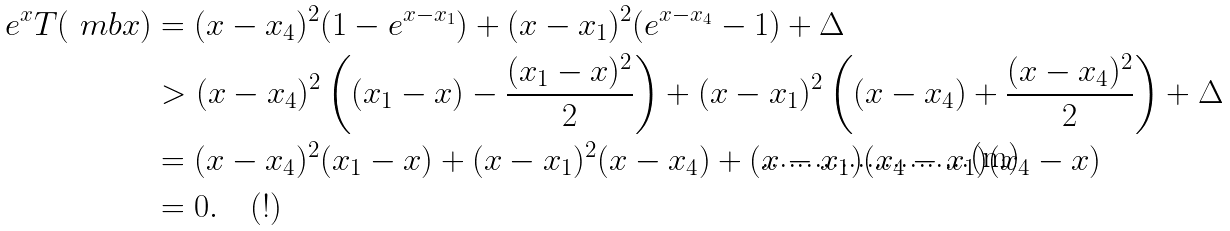Convert formula to latex. <formula><loc_0><loc_0><loc_500><loc_500>e ^ { x } T ( \ m b x ) & = ( x - x _ { 4 } ) ^ { 2 } ( 1 - e ^ { x - x _ { 1 } } ) + ( x - x _ { 1 } ) ^ { 2 } ( e ^ { x - x _ { 4 } } - 1 ) + \Delta \\ & > ( x - x _ { 4 } ) ^ { 2 } \left ( ( x _ { 1 } - x ) - \frac { ( x _ { 1 } - x ) ^ { 2 } } { 2 } \right ) + ( x - x _ { 1 } ) ^ { 2 } \left ( ( x - x _ { 4 } ) + \frac { ( x - x _ { 4 } ) ^ { 2 } } { 2 } \right ) + \Delta \\ & = ( x - x _ { 4 } ) ^ { 2 } ( x _ { 1 } - x ) + ( x - x _ { 1 } ) ^ { 2 } ( x - x _ { 4 } ) + ( x - x _ { 1 } ) ( x _ { 4 } - x _ { 1 } ) ( x _ { 4 } - x ) \\ & = 0 . \quad ( ! )</formula> 